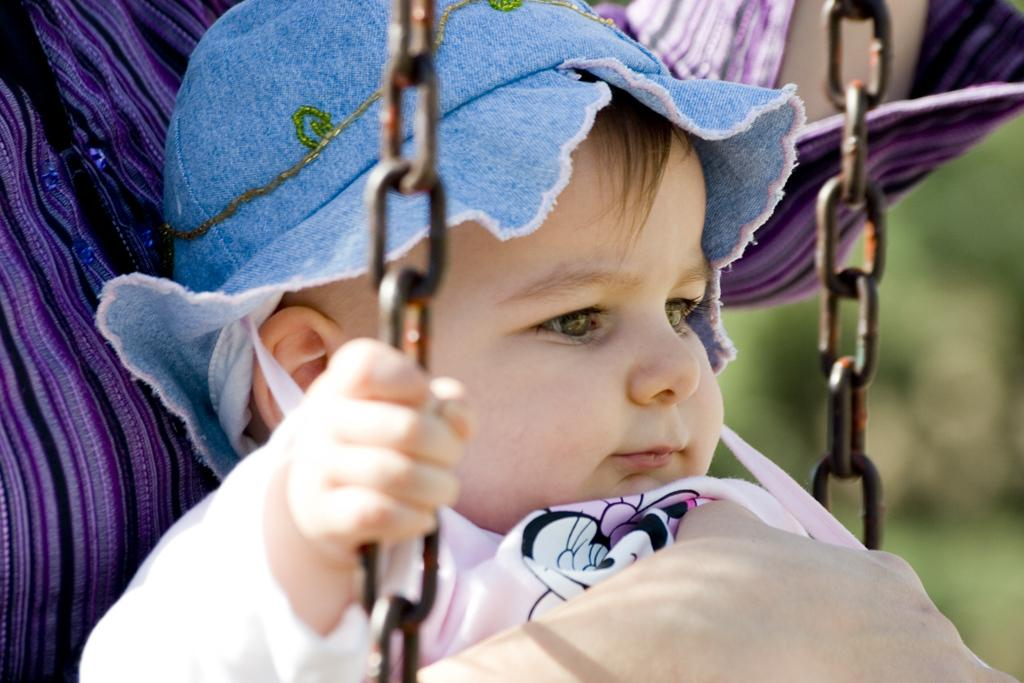What is the main subject of the image? There is a baby in the image. What is the baby doing in the image? The baby is sitting on a swing. What is the baby wearing on their head? The baby is wearing a blue cap. What is the baby wearing on their body? The baby is wearing a colorful dress. Can you describe the background of the image? The background of the image is blurred. What type of poison is the baby holding in the image? There is no poison present in the image; the baby is sitting on a swing and wearing a blue cap and a colorful dress. 